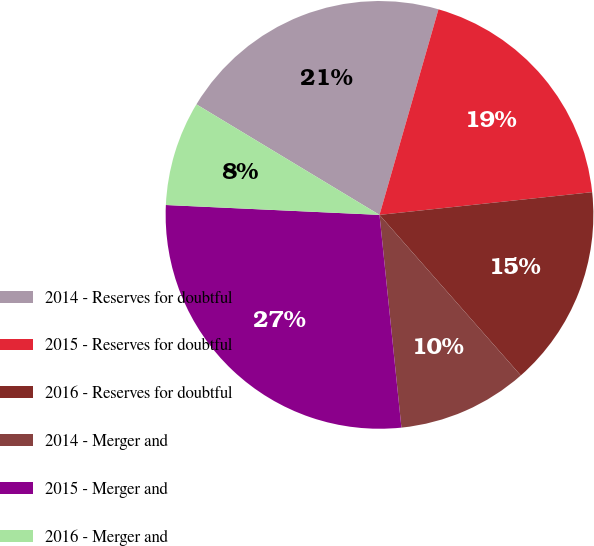<chart> <loc_0><loc_0><loc_500><loc_500><pie_chart><fcel>2014 - Reserves for doubtful<fcel>2015 - Reserves for doubtful<fcel>2016 - Reserves for doubtful<fcel>2014 - Merger and<fcel>2015 - Merger and<fcel>2016 - Merger and<nl><fcel>20.8%<fcel>18.86%<fcel>15.21%<fcel>9.85%<fcel>27.37%<fcel>7.91%<nl></chart> 